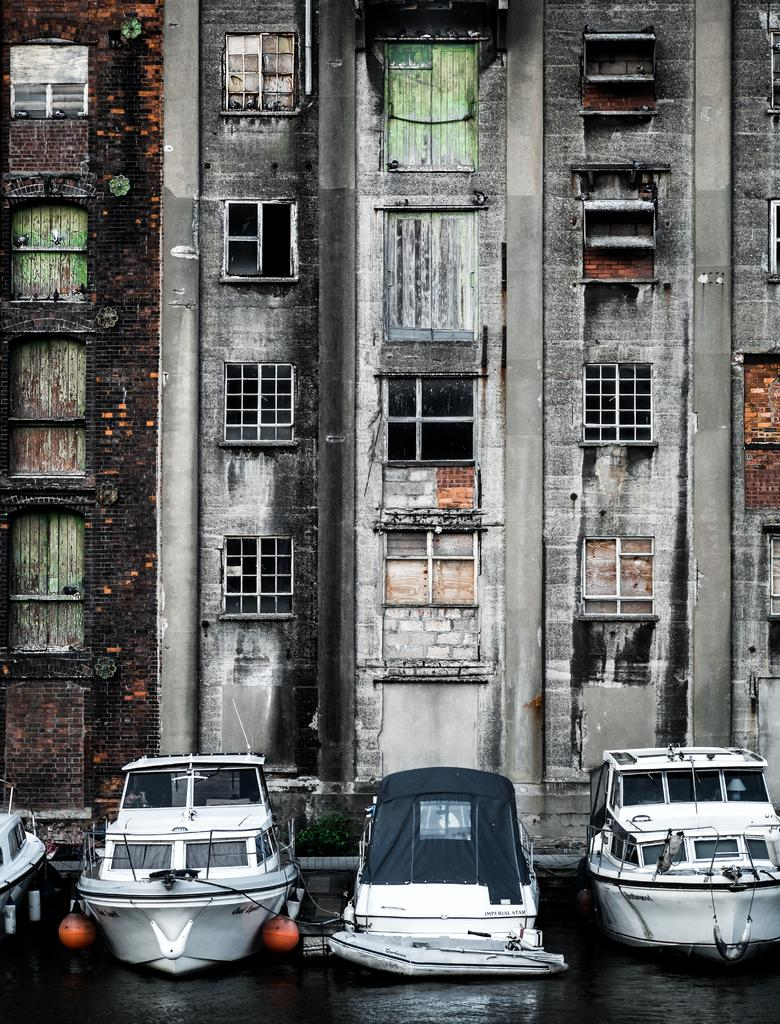What is at the bottom of the image? There is water at the bottom of the image. What is floating on the water? There are four boats in the water. What can be seen in the background of the image? There is a building in the background of the image. What feature of the building is visible? Windows are visible on the building. What type of rod is being used to catch fish in the image? There is no rod or fishing activity depicted in the image. 